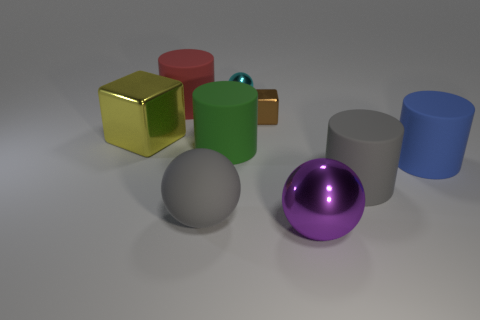What is the material of the ball that is in front of the small cyan thing and behind the large purple metallic ball?
Your answer should be very brief. Rubber. Is the size of the sphere that is to the right of the cyan ball the same as the yellow cube?
Keep it short and to the point. Yes. What is the material of the yellow cube?
Provide a short and direct response. Metal. What color is the large metal object that is in front of the large blue matte thing?
Offer a terse response. Purple. How many tiny objects are either brown shiny cubes or blue metallic cylinders?
Offer a terse response. 1. There is a small thing in front of the tiny cyan metal ball; is it the same color as the big sphere behind the large purple metal sphere?
Provide a short and direct response. No. How many other objects are the same color as the rubber sphere?
Offer a terse response. 1. How many gray things are large shiny things or metal blocks?
Make the answer very short. 0. Do the green matte thing and the metallic thing that is in front of the gray sphere have the same shape?
Offer a terse response. No. The big yellow shiny object has what shape?
Provide a short and direct response. Cube. 